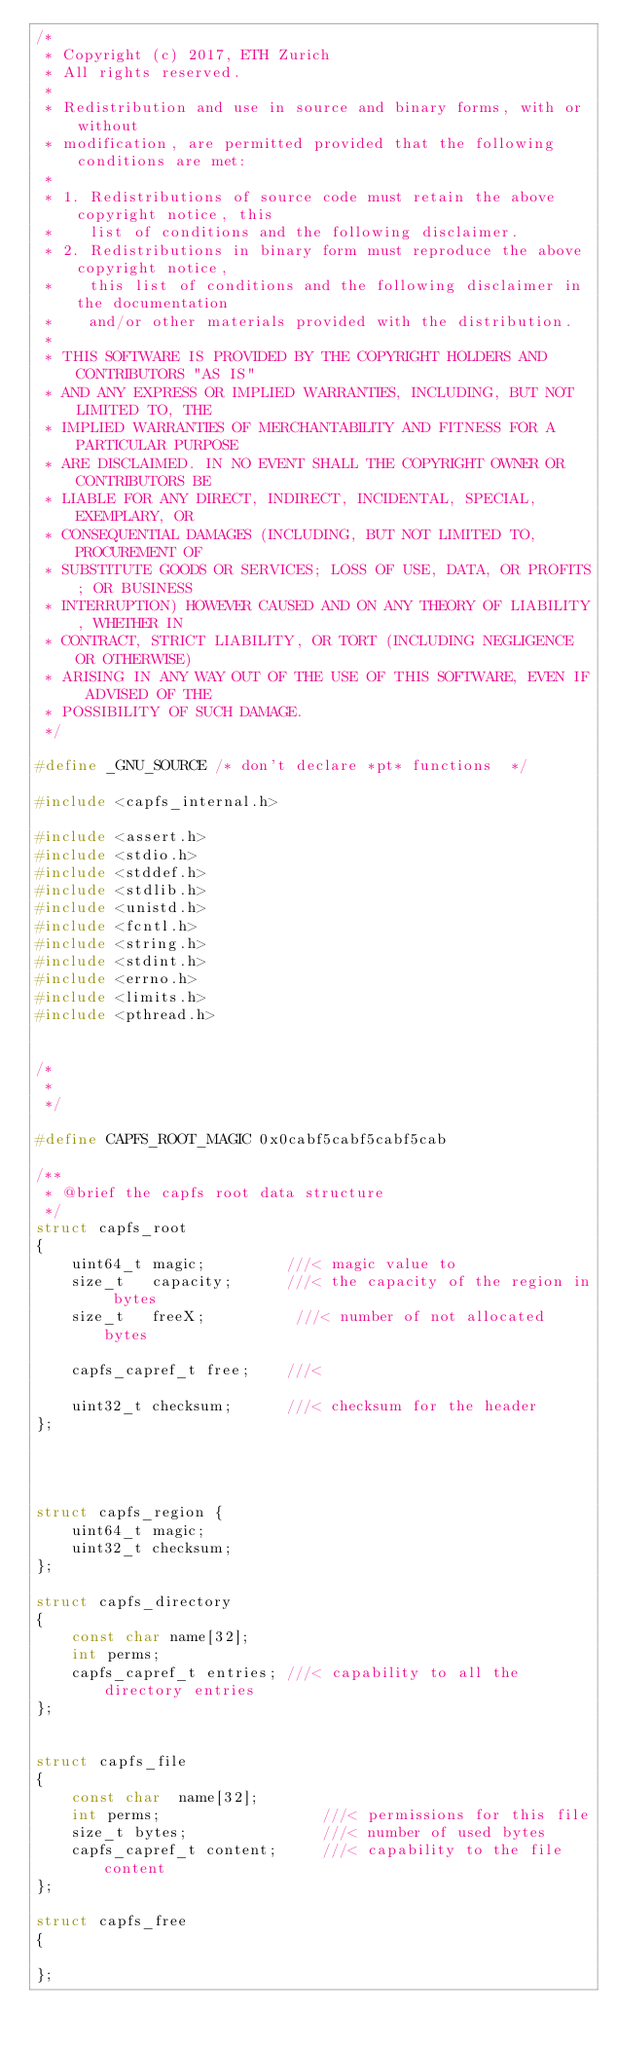Convert code to text. <code><loc_0><loc_0><loc_500><loc_500><_C_>/*
 * Copyright (c) 2017, ETH Zurich
 * All rights reserved.
 *
 * Redistribution and use in source and binary forms, with or without
 * modification, are permitted provided that the following conditions are met:
 *
 * 1. Redistributions of source code must retain the above copyright notice, this
 *    list of conditions and the following disclaimer.
 * 2. Redistributions in binary form must reproduce the above copyright notice,
 *    this list of conditions and the following disclaimer in the documentation
 *    and/or other materials provided with the distribution.
 *
 * THIS SOFTWARE IS PROVIDED BY THE COPYRIGHT HOLDERS AND CONTRIBUTORS "AS IS"
 * AND ANY EXPRESS OR IMPLIED WARRANTIES, INCLUDING, BUT NOT LIMITED TO, THE
 * IMPLIED WARRANTIES OF MERCHANTABILITY AND FITNESS FOR A PARTICULAR PURPOSE
 * ARE DISCLAIMED. IN NO EVENT SHALL THE COPYRIGHT OWNER OR CONTRIBUTORS BE
 * LIABLE FOR ANY DIRECT, INDIRECT, INCIDENTAL, SPECIAL, EXEMPLARY, OR
 * CONSEQUENTIAL DAMAGES (INCLUDING, BUT NOT LIMITED TO, PROCUREMENT OF
 * SUBSTITUTE GOODS OR SERVICES; LOSS OF USE, DATA, OR PROFITS; OR BUSINESS
 * INTERRUPTION) HOWEVER CAUSED AND ON ANY THEORY OF LIABILITY, WHETHER IN
 * CONTRACT, STRICT LIABILITY, OR TORT (INCLUDING NEGLIGENCE OR OTHERWISE)
 * ARISING IN ANY WAY OUT OF THE USE OF THIS SOFTWARE, EVEN IF ADVISED OF THE
 * POSSIBILITY OF SUCH DAMAGE.
 */

#define _GNU_SOURCE /* don't declare *pt* functions  */

#include <capfs_internal.h>

#include <assert.h>
#include <stdio.h>
#include <stddef.h>
#include <stdlib.h>
#include <unistd.h>
#include <fcntl.h>
#include <string.h>
#include <stdint.h>
#include <errno.h>
#include <limits.h>
#include <pthread.h>


/*
 *
 */

#define CAPFS_ROOT_MAGIC 0x0cabf5cabf5cabf5cab

/**
 * @brief the capfs root data structure
 */
struct capfs_root
{
    uint64_t magic;         ///< magic value to
    size_t   capacity;      ///< the capacity of the region in bytes
    size_t   freeX;          ///< number of not allocated bytes

    capfs_capref_t free;    ///<

    uint32_t checksum;      ///< checksum for the header
};




struct capfs_region {
    uint64_t magic;
    uint32_t checksum;
};

struct capfs_directory
{
    const char name[32];
    int perms;
    capfs_capref_t entries; ///< capability to all the directory entries
};


struct capfs_file
{
    const char  name[32];
    int perms;                  ///< permissions for this file
    size_t bytes;               ///< number of used bytes
    capfs_capref_t content;     ///< capability to the file content
};

struct capfs_free
{

};</code> 